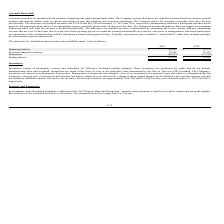According to Telkonet's financial document, What is the allowance for doubtful accounts at December 31, 2019? According to the financial document, $55,039. The relevant text states: "llectible. The allowance for doubtful accounts was $55,039 and $65,542 at December 31, 2019 and 2018, respectively. Management identifies a delinquent customer..." Also, When are accounts receivable written off? when they become uncollectible. The document states: "tions. The Company writes off accounts receivable when they become uncollectible. The allowance for doubtful accounts was $55,039 and $65,542 at Decem..." Also, When are accounts escalated to "uncollectible" status? after multiple attempts at collection have proven unsuccessful. The document states: "unts are only escalated to “uncollectible” status after multiple attempts at collection have proven unsuccessful. The allowance for doubtful accounts ..." Additionally, Which year has the higher deductions? According to the financial document, 2019. The relevant text states: "accounts was $55,039 and $65,542 at December 31, 2019 and 2018, respectively. Management identifies a delinquent customer based upon the delinquent payme..." Also, can you calculate: What is the percentage change in the ending balance of allowance for doubtful accounts from 2018 to 2019? To answer this question, I need to perform calculations using the financial data. The calculation is: (55,039-65,542)/65,542, which equals -16.02 (percentage). This is based on the information: "ectible. The allowance for doubtful accounts was $55,039 and $65,542 at December 31, 2019 and 2018, respectively. Management identifies a delinquent custome allowance for doubtful accounts was $55,039..." The key data points involved are: 55,039, 65,542. Also, can you calculate: What is the change in beginning balance of allowance of doubtful accounts from 2018 to 2019? Based on the calculation: 65,542-22,173, the result is 43369. This is based on the information: "allowance for doubtful accounts was $55,039 and $65,542 at December 31, 2019 and 2018, respectively. Management identifies a delinquent customer based upon Beginning balance $ 65,542 $ 22,173..." The key data points involved are: 22,173, 65,542. 